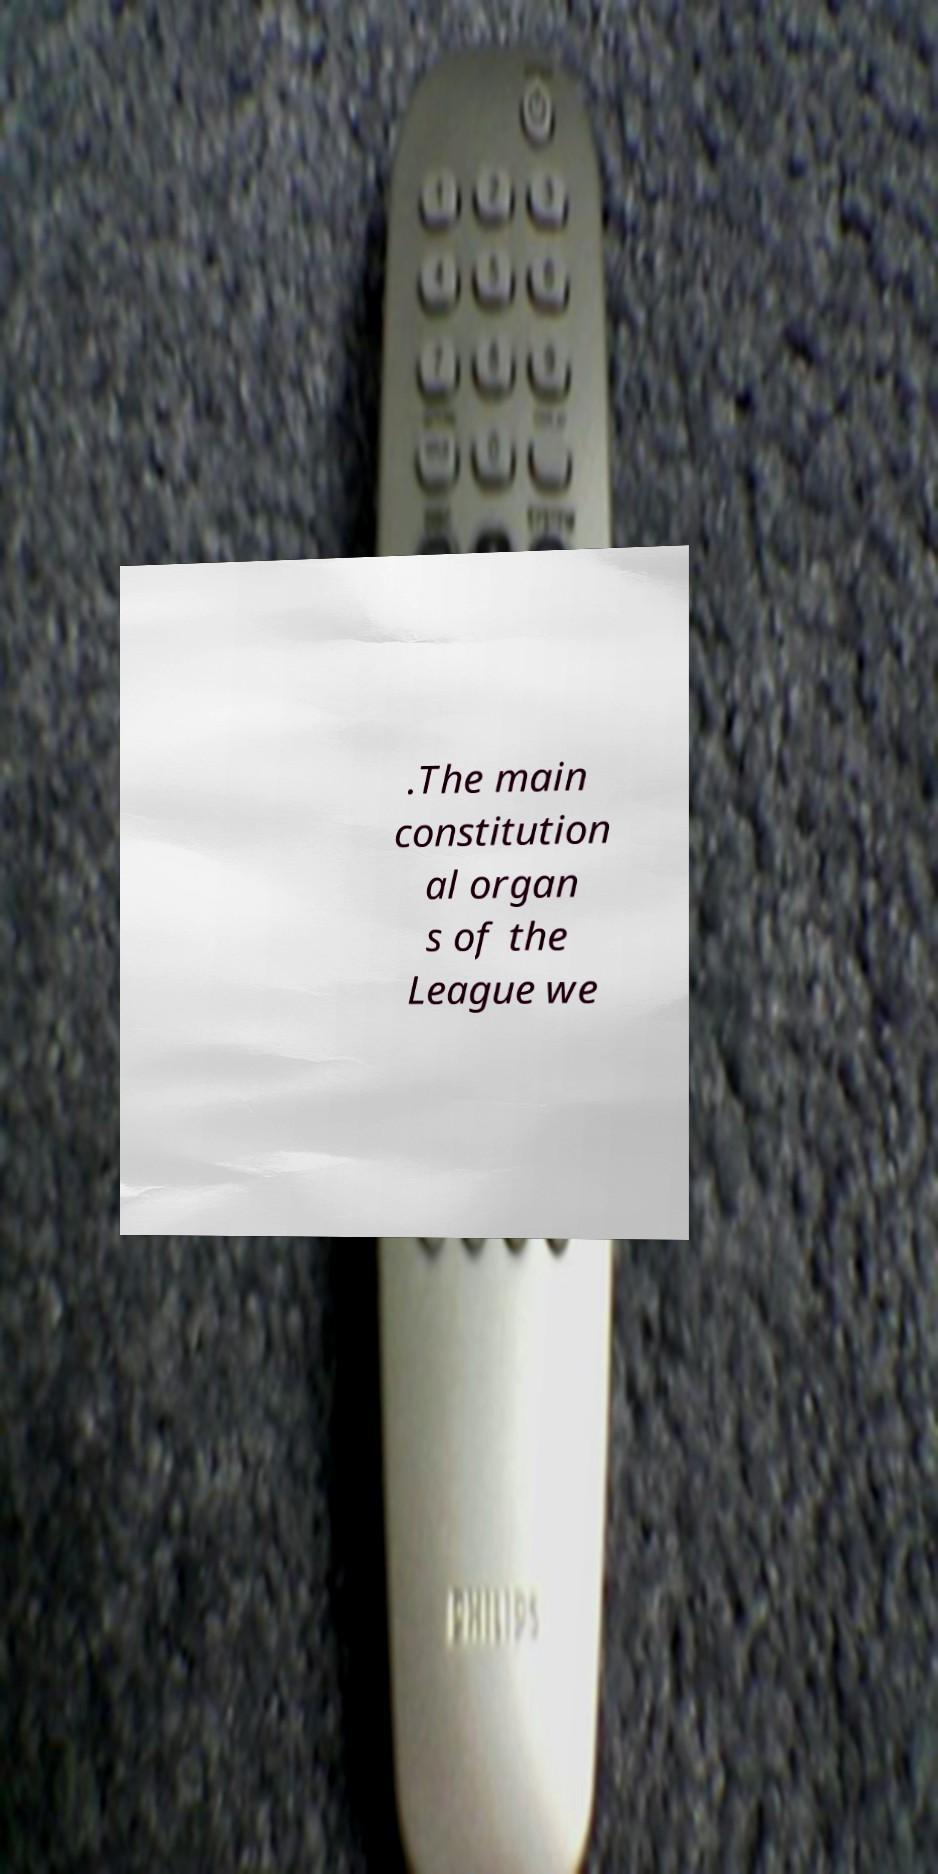Could you extract and type out the text from this image? .The main constitution al organ s of the League we 